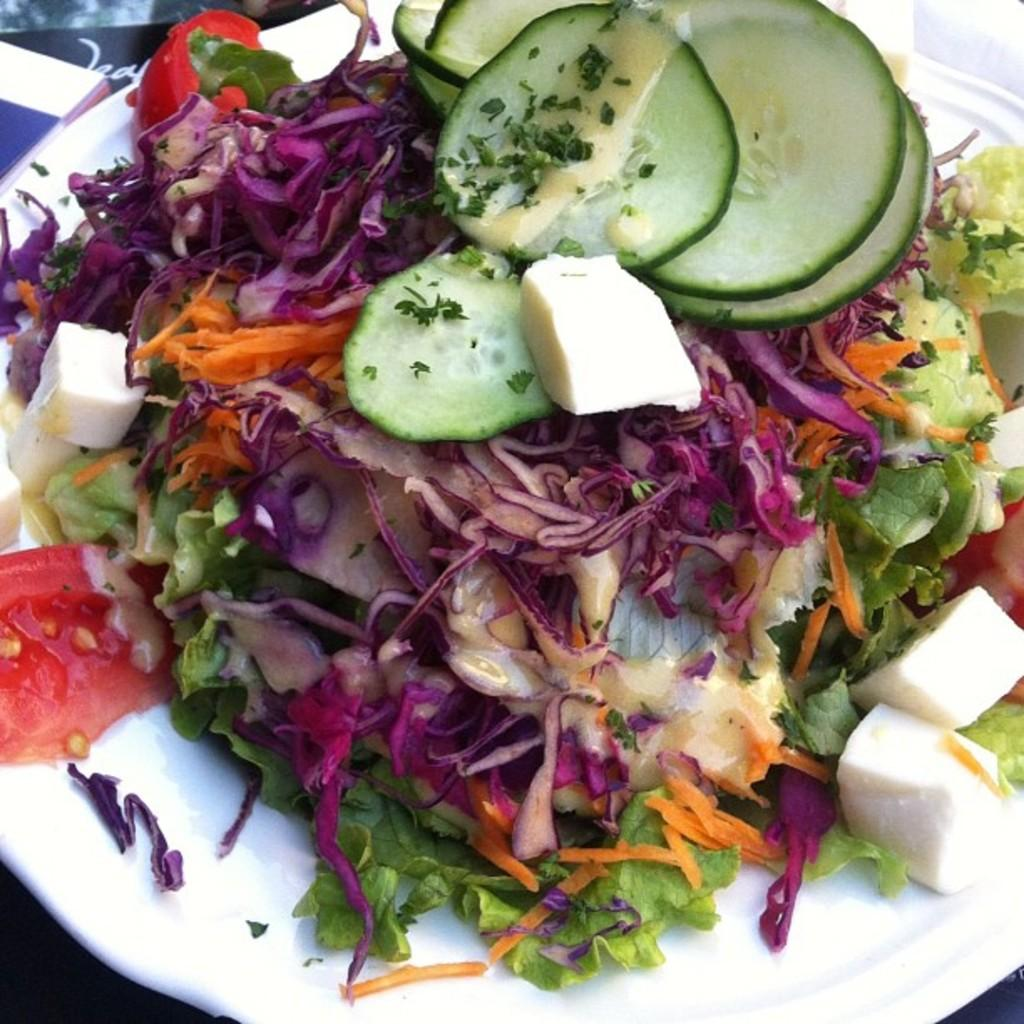What is the main object in the center of the image? There is a plate in the center of the image. What types of vegetables are on the plate? The plate contains cucumber, tomato, and beetroot. What type of potato is featured on the calendar in the image? There is no calendar or potato present in the image; it only features a plate with cucumber, tomato, and beetroot. How many chickens are visible on the plate in the image? There are no chickens present on the plate in the image; it contains only cucumber, tomato, and beetroot. 